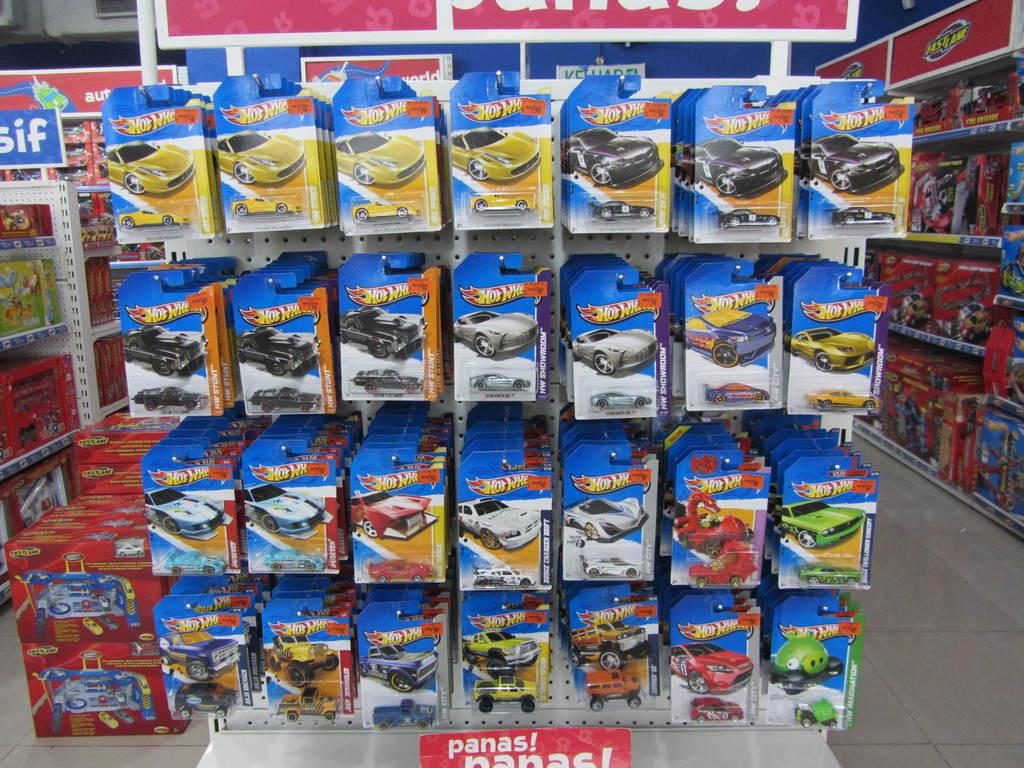<image>
Provide a brief description of the given image. A row of hot wheel cars are lined up over a sign in a toy store that says Panas. 